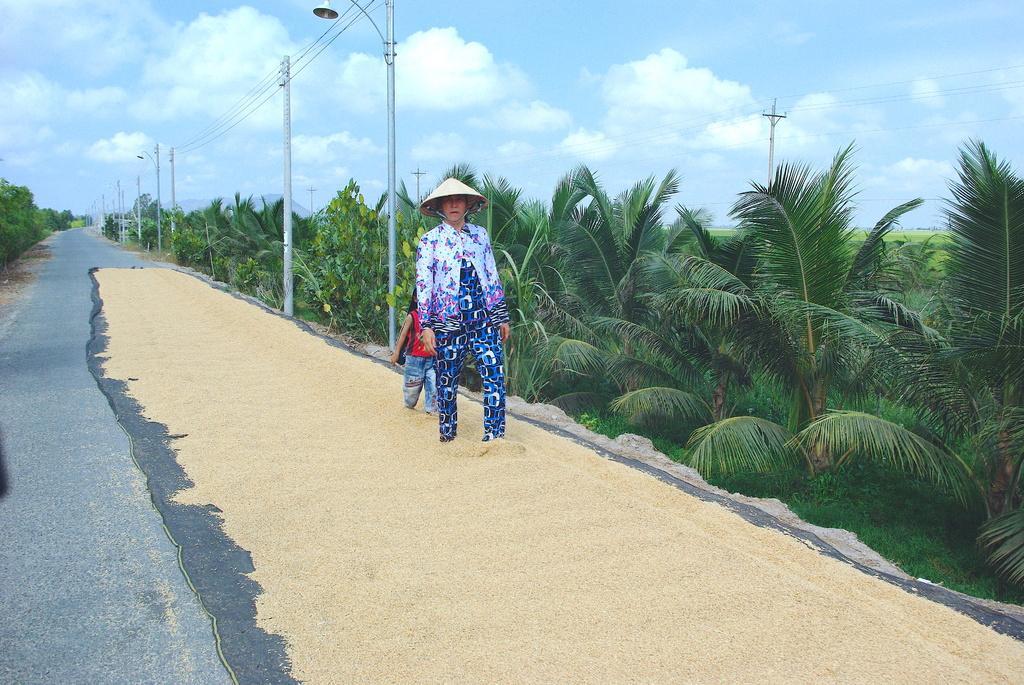Describe this image in one or two sentences. In this picture there is a woman standing and there is a boy standing behind the woman. There are wheat grains on the road. On the left and on the right side of the image there are trees and there are poles and there are wires on the poles. At the top there is sky and there are clouds. At the bottom there is a road. 